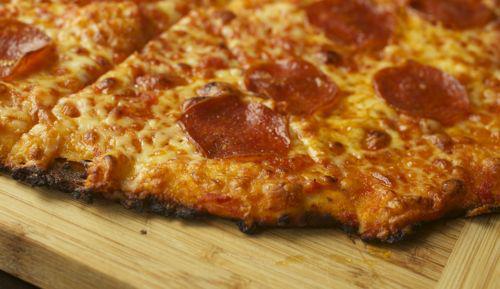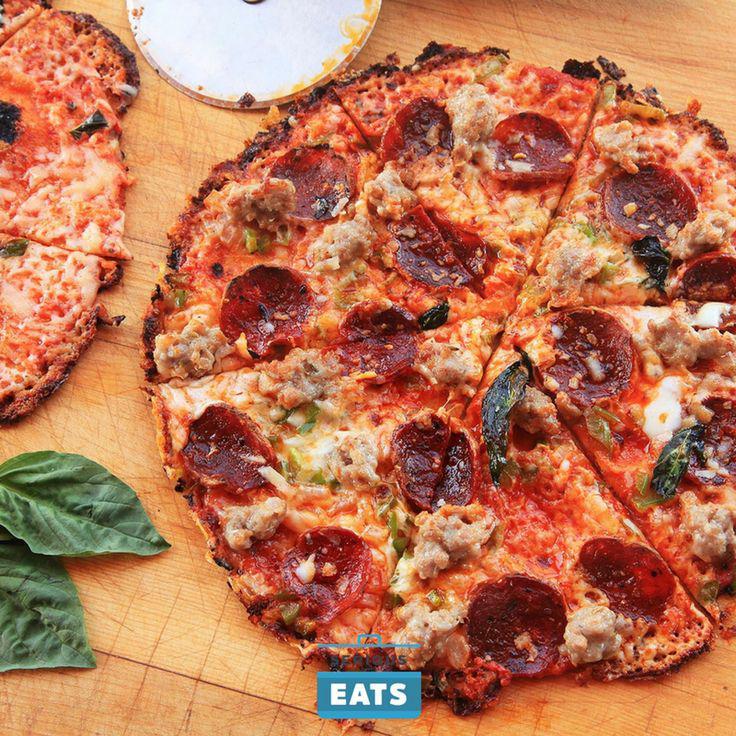The first image is the image on the left, the second image is the image on the right. Given the left and right images, does the statement "Each of the pizzas has been cut into individual pieces." hold true? Answer yes or no. Yes. The first image is the image on the left, the second image is the image on the right. Analyze the images presented: Is the assertion "There is pepperoni on one pizza but not the other." valid? Answer yes or no. No. 